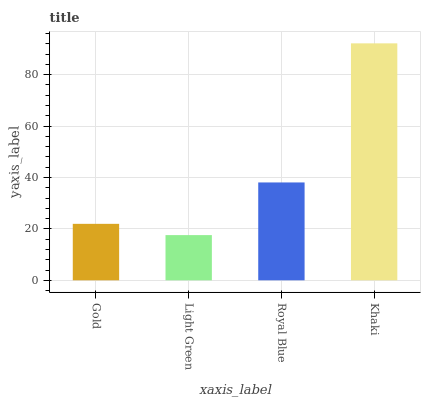Is Light Green the minimum?
Answer yes or no. Yes. Is Khaki the maximum?
Answer yes or no. Yes. Is Royal Blue the minimum?
Answer yes or no. No. Is Royal Blue the maximum?
Answer yes or no. No. Is Royal Blue greater than Light Green?
Answer yes or no. Yes. Is Light Green less than Royal Blue?
Answer yes or no. Yes. Is Light Green greater than Royal Blue?
Answer yes or no. No. Is Royal Blue less than Light Green?
Answer yes or no. No. Is Royal Blue the high median?
Answer yes or no. Yes. Is Gold the low median?
Answer yes or no. Yes. Is Khaki the high median?
Answer yes or no. No. Is Light Green the low median?
Answer yes or no. No. 